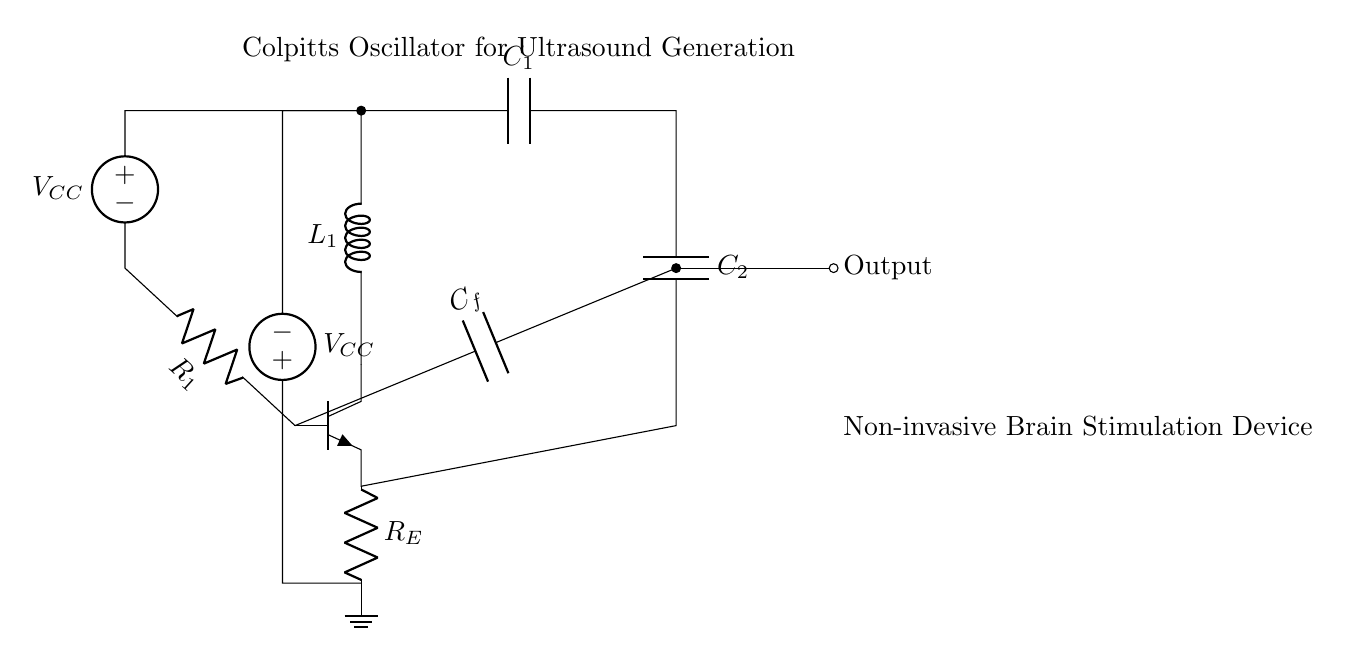What type of oscillator is shown in the circuit? The circuit is a Colpitts oscillator, identified by the presence of a tank circuit that uses capacitors and an inductor for oscillation.
Answer: Colpitts oscillator What is the role of the capacitors in this circuit? The capacitors, specifically C1 and C2, form part of the feedback network which determines the oscillation frequency of the Colpitts oscillator together with the inductor.
Answer: Feedback network What is the significance of the feedback capacitor C_f? The feedback capacitor C_f connects the output back to the base of the transistor, crucial for maintaining oscillations by providing the necessary phase shift.
Answer: Necessary phase shift What components comprise the tank circuit? The tank circuit consists of an inductor L1 and two capacitors C1 and C2, which are responsible for creating the resonant frequency.
Answer: Inductor and two capacitors What is the purpose of the biasing resistors R1 and R_E? The biasing resistor R1 sets the base current for the transistor while R_E stabilizes the operating point, ensuring reliable oscillation.
Answer: Set base current and stabilize operating point What determines the output frequency of the oscillator? The output frequency is determined by the values of L1, C1, and C2 based on the resonant frequency formula for a Colpitts oscillator, which takes into account these components' values.
Answer: Values of L1, C1, and C2 